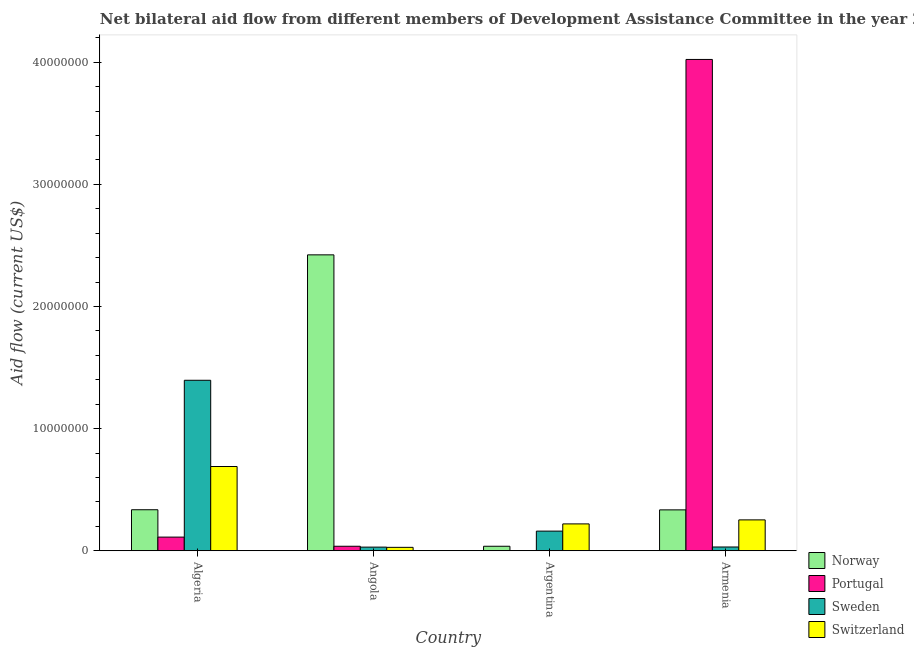How many different coloured bars are there?
Give a very brief answer. 4. Are the number of bars on each tick of the X-axis equal?
Make the answer very short. Yes. What is the label of the 2nd group of bars from the left?
Your response must be concise. Angola. What is the amount of aid given by switzerland in Algeria?
Offer a terse response. 6.90e+06. Across all countries, what is the maximum amount of aid given by portugal?
Ensure brevity in your answer.  4.02e+07. Across all countries, what is the minimum amount of aid given by norway?
Your answer should be very brief. 3.70e+05. In which country was the amount of aid given by sweden maximum?
Provide a short and direct response. Algeria. What is the total amount of aid given by portugal in the graph?
Offer a terse response. 4.17e+07. What is the difference between the amount of aid given by portugal in Angola and that in Armenia?
Make the answer very short. -3.99e+07. What is the difference between the amount of aid given by sweden in Angola and the amount of aid given by switzerland in Algeria?
Provide a succinct answer. -6.60e+06. What is the average amount of aid given by sweden per country?
Keep it short and to the point. 4.04e+06. What is the difference between the amount of aid given by portugal and amount of aid given by switzerland in Angola?
Ensure brevity in your answer.  9.00e+04. What is the ratio of the amount of aid given by norway in Argentina to that in Armenia?
Provide a succinct answer. 0.11. Is the amount of aid given by switzerland in Argentina less than that in Armenia?
Keep it short and to the point. Yes. What is the difference between the highest and the second highest amount of aid given by portugal?
Your answer should be very brief. 3.91e+07. What is the difference between the highest and the lowest amount of aid given by switzerland?
Keep it short and to the point. 6.62e+06. Is it the case that in every country, the sum of the amount of aid given by switzerland and amount of aid given by portugal is greater than the sum of amount of aid given by norway and amount of aid given by sweden?
Your response must be concise. No. What does the 1st bar from the right in Armenia represents?
Offer a very short reply. Switzerland. Is it the case that in every country, the sum of the amount of aid given by norway and amount of aid given by portugal is greater than the amount of aid given by sweden?
Provide a succinct answer. No. What is the difference between two consecutive major ticks on the Y-axis?
Your answer should be very brief. 1.00e+07. Are the values on the major ticks of Y-axis written in scientific E-notation?
Offer a very short reply. No. How many legend labels are there?
Your answer should be compact. 4. How are the legend labels stacked?
Ensure brevity in your answer.  Vertical. What is the title of the graph?
Offer a very short reply. Net bilateral aid flow from different members of Development Assistance Committee in the year 2003. Does "Manufacturing" appear as one of the legend labels in the graph?
Offer a very short reply. No. What is the label or title of the Y-axis?
Keep it short and to the point. Aid flow (current US$). What is the Aid flow (current US$) in Norway in Algeria?
Offer a very short reply. 3.36e+06. What is the Aid flow (current US$) in Portugal in Algeria?
Offer a very short reply. 1.12e+06. What is the Aid flow (current US$) of Sweden in Algeria?
Offer a very short reply. 1.40e+07. What is the Aid flow (current US$) in Switzerland in Algeria?
Provide a short and direct response. 6.90e+06. What is the Aid flow (current US$) in Norway in Angola?
Offer a terse response. 2.42e+07. What is the Aid flow (current US$) in Portugal in Angola?
Keep it short and to the point. 3.70e+05. What is the Aid flow (current US$) in Norway in Argentina?
Ensure brevity in your answer.  3.70e+05. What is the Aid flow (current US$) in Sweden in Argentina?
Offer a terse response. 1.61e+06. What is the Aid flow (current US$) of Switzerland in Argentina?
Ensure brevity in your answer.  2.20e+06. What is the Aid flow (current US$) of Norway in Armenia?
Ensure brevity in your answer.  3.35e+06. What is the Aid flow (current US$) of Portugal in Armenia?
Offer a terse response. 4.02e+07. What is the Aid flow (current US$) of Switzerland in Armenia?
Your answer should be very brief. 2.53e+06. Across all countries, what is the maximum Aid flow (current US$) of Norway?
Give a very brief answer. 2.42e+07. Across all countries, what is the maximum Aid flow (current US$) in Portugal?
Offer a very short reply. 4.02e+07. Across all countries, what is the maximum Aid flow (current US$) of Sweden?
Provide a succinct answer. 1.40e+07. Across all countries, what is the maximum Aid flow (current US$) in Switzerland?
Give a very brief answer. 6.90e+06. Across all countries, what is the minimum Aid flow (current US$) in Portugal?
Your answer should be very brief. 10000. What is the total Aid flow (current US$) of Norway in the graph?
Keep it short and to the point. 3.13e+07. What is the total Aid flow (current US$) in Portugal in the graph?
Make the answer very short. 4.17e+07. What is the total Aid flow (current US$) in Sweden in the graph?
Provide a short and direct response. 1.62e+07. What is the total Aid flow (current US$) of Switzerland in the graph?
Keep it short and to the point. 1.19e+07. What is the difference between the Aid flow (current US$) in Norway in Algeria and that in Angola?
Keep it short and to the point. -2.09e+07. What is the difference between the Aid flow (current US$) in Portugal in Algeria and that in Angola?
Keep it short and to the point. 7.50e+05. What is the difference between the Aid flow (current US$) in Sweden in Algeria and that in Angola?
Your answer should be compact. 1.37e+07. What is the difference between the Aid flow (current US$) in Switzerland in Algeria and that in Angola?
Your response must be concise. 6.62e+06. What is the difference between the Aid flow (current US$) in Norway in Algeria and that in Argentina?
Your answer should be compact. 2.99e+06. What is the difference between the Aid flow (current US$) in Portugal in Algeria and that in Argentina?
Your answer should be very brief. 1.11e+06. What is the difference between the Aid flow (current US$) of Sweden in Algeria and that in Argentina?
Provide a short and direct response. 1.24e+07. What is the difference between the Aid flow (current US$) in Switzerland in Algeria and that in Argentina?
Provide a succinct answer. 4.70e+06. What is the difference between the Aid flow (current US$) in Norway in Algeria and that in Armenia?
Your answer should be very brief. 10000. What is the difference between the Aid flow (current US$) of Portugal in Algeria and that in Armenia?
Make the answer very short. -3.91e+07. What is the difference between the Aid flow (current US$) of Sweden in Algeria and that in Armenia?
Offer a very short reply. 1.36e+07. What is the difference between the Aid flow (current US$) in Switzerland in Algeria and that in Armenia?
Provide a short and direct response. 4.37e+06. What is the difference between the Aid flow (current US$) of Norway in Angola and that in Argentina?
Provide a short and direct response. 2.39e+07. What is the difference between the Aid flow (current US$) in Portugal in Angola and that in Argentina?
Ensure brevity in your answer.  3.60e+05. What is the difference between the Aid flow (current US$) in Sweden in Angola and that in Argentina?
Your answer should be compact. -1.31e+06. What is the difference between the Aid flow (current US$) in Switzerland in Angola and that in Argentina?
Keep it short and to the point. -1.92e+06. What is the difference between the Aid flow (current US$) in Norway in Angola and that in Armenia?
Keep it short and to the point. 2.09e+07. What is the difference between the Aid flow (current US$) of Portugal in Angola and that in Armenia?
Your answer should be very brief. -3.99e+07. What is the difference between the Aid flow (current US$) in Switzerland in Angola and that in Armenia?
Offer a terse response. -2.25e+06. What is the difference between the Aid flow (current US$) in Norway in Argentina and that in Armenia?
Your response must be concise. -2.98e+06. What is the difference between the Aid flow (current US$) in Portugal in Argentina and that in Armenia?
Make the answer very short. -4.02e+07. What is the difference between the Aid flow (current US$) of Sweden in Argentina and that in Armenia?
Provide a succinct answer. 1.30e+06. What is the difference between the Aid flow (current US$) in Switzerland in Argentina and that in Armenia?
Provide a short and direct response. -3.30e+05. What is the difference between the Aid flow (current US$) in Norway in Algeria and the Aid flow (current US$) in Portugal in Angola?
Give a very brief answer. 2.99e+06. What is the difference between the Aid flow (current US$) of Norway in Algeria and the Aid flow (current US$) of Sweden in Angola?
Offer a very short reply. 3.06e+06. What is the difference between the Aid flow (current US$) of Norway in Algeria and the Aid flow (current US$) of Switzerland in Angola?
Your answer should be very brief. 3.08e+06. What is the difference between the Aid flow (current US$) of Portugal in Algeria and the Aid flow (current US$) of Sweden in Angola?
Give a very brief answer. 8.20e+05. What is the difference between the Aid flow (current US$) of Portugal in Algeria and the Aid flow (current US$) of Switzerland in Angola?
Make the answer very short. 8.40e+05. What is the difference between the Aid flow (current US$) of Sweden in Algeria and the Aid flow (current US$) of Switzerland in Angola?
Provide a succinct answer. 1.37e+07. What is the difference between the Aid flow (current US$) in Norway in Algeria and the Aid flow (current US$) in Portugal in Argentina?
Your answer should be compact. 3.35e+06. What is the difference between the Aid flow (current US$) of Norway in Algeria and the Aid flow (current US$) of Sweden in Argentina?
Ensure brevity in your answer.  1.75e+06. What is the difference between the Aid flow (current US$) in Norway in Algeria and the Aid flow (current US$) in Switzerland in Argentina?
Offer a terse response. 1.16e+06. What is the difference between the Aid flow (current US$) in Portugal in Algeria and the Aid flow (current US$) in Sweden in Argentina?
Offer a terse response. -4.90e+05. What is the difference between the Aid flow (current US$) in Portugal in Algeria and the Aid flow (current US$) in Switzerland in Argentina?
Make the answer very short. -1.08e+06. What is the difference between the Aid flow (current US$) in Sweden in Algeria and the Aid flow (current US$) in Switzerland in Argentina?
Provide a succinct answer. 1.18e+07. What is the difference between the Aid flow (current US$) in Norway in Algeria and the Aid flow (current US$) in Portugal in Armenia?
Your response must be concise. -3.69e+07. What is the difference between the Aid flow (current US$) in Norway in Algeria and the Aid flow (current US$) in Sweden in Armenia?
Give a very brief answer. 3.05e+06. What is the difference between the Aid flow (current US$) of Norway in Algeria and the Aid flow (current US$) of Switzerland in Armenia?
Provide a short and direct response. 8.30e+05. What is the difference between the Aid flow (current US$) of Portugal in Algeria and the Aid flow (current US$) of Sweden in Armenia?
Provide a succinct answer. 8.10e+05. What is the difference between the Aid flow (current US$) in Portugal in Algeria and the Aid flow (current US$) in Switzerland in Armenia?
Provide a short and direct response. -1.41e+06. What is the difference between the Aid flow (current US$) in Sweden in Algeria and the Aid flow (current US$) in Switzerland in Armenia?
Ensure brevity in your answer.  1.14e+07. What is the difference between the Aid flow (current US$) in Norway in Angola and the Aid flow (current US$) in Portugal in Argentina?
Offer a very short reply. 2.42e+07. What is the difference between the Aid flow (current US$) in Norway in Angola and the Aid flow (current US$) in Sweden in Argentina?
Your response must be concise. 2.26e+07. What is the difference between the Aid flow (current US$) in Norway in Angola and the Aid flow (current US$) in Switzerland in Argentina?
Ensure brevity in your answer.  2.20e+07. What is the difference between the Aid flow (current US$) of Portugal in Angola and the Aid flow (current US$) of Sweden in Argentina?
Your response must be concise. -1.24e+06. What is the difference between the Aid flow (current US$) of Portugal in Angola and the Aid flow (current US$) of Switzerland in Argentina?
Offer a very short reply. -1.83e+06. What is the difference between the Aid flow (current US$) in Sweden in Angola and the Aid flow (current US$) in Switzerland in Argentina?
Your response must be concise. -1.90e+06. What is the difference between the Aid flow (current US$) in Norway in Angola and the Aid flow (current US$) in Portugal in Armenia?
Your answer should be very brief. -1.60e+07. What is the difference between the Aid flow (current US$) of Norway in Angola and the Aid flow (current US$) of Sweden in Armenia?
Your answer should be very brief. 2.39e+07. What is the difference between the Aid flow (current US$) of Norway in Angola and the Aid flow (current US$) of Switzerland in Armenia?
Offer a very short reply. 2.17e+07. What is the difference between the Aid flow (current US$) of Portugal in Angola and the Aid flow (current US$) of Switzerland in Armenia?
Your response must be concise. -2.16e+06. What is the difference between the Aid flow (current US$) of Sweden in Angola and the Aid flow (current US$) of Switzerland in Armenia?
Make the answer very short. -2.23e+06. What is the difference between the Aid flow (current US$) in Norway in Argentina and the Aid flow (current US$) in Portugal in Armenia?
Your response must be concise. -3.99e+07. What is the difference between the Aid flow (current US$) in Norway in Argentina and the Aid flow (current US$) in Sweden in Armenia?
Give a very brief answer. 6.00e+04. What is the difference between the Aid flow (current US$) of Norway in Argentina and the Aid flow (current US$) of Switzerland in Armenia?
Your answer should be compact. -2.16e+06. What is the difference between the Aid flow (current US$) of Portugal in Argentina and the Aid flow (current US$) of Sweden in Armenia?
Your answer should be compact. -3.00e+05. What is the difference between the Aid flow (current US$) in Portugal in Argentina and the Aid flow (current US$) in Switzerland in Armenia?
Offer a terse response. -2.52e+06. What is the difference between the Aid flow (current US$) in Sweden in Argentina and the Aid flow (current US$) in Switzerland in Armenia?
Give a very brief answer. -9.20e+05. What is the average Aid flow (current US$) in Norway per country?
Offer a terse response. 7.83e+06. What is the average Aid flow (current US$) in Portugal per country?
Provide a succinct answer. 1.04e+07. What is the average Aid flow (current US$) in Sweden per country?
Make the answer very short. 4.04e+06. What is the average Aid flow (current US$) in Switzerland per country?
Offer a very short reply. 2.98e+06. What is the difference between the Aid flow (current US$) in Norway and Aid flow (current US$) in Portugal in Algeria?
Your response must be concise. 2.24e+06. What is the difference between the Aid flow (current US$) of Norway and Aid flow (current US$) of Sweden in Algeria?
Make the answer very short. -1.06e+07. What is the difference between the Aid flow (current US$) of Norway and Aid flow (current US$) of Switzerland in Algeria?
Offer a terse response. -3.54e+06. What is the difference between the Aid flow (current US$) in Portugal and Aid flow (current US$) in Sweden in Algeria?
Your response must be concise. -1.28e+07. What is the difference between the Aid flow (current US$) in Portugal and Aid flow (current US$) in Switzerland in Algeria?
Give a very brief answer. -5.78e+06. What is the difference between the Aid flow (current US$) of Sweden and Aid flow (current US$) of Switzerland in Algeria?
Give a very brief answer. 7.06e+06. What is the difference between the Aid flow (current US$) of Norway and Aid flow (current US$) of Portugal in Angola?
Provide a succinct answer. 2.39e+07. What is the difference between the Aid flow (current US$) of Norway and Aid flow (current US$) of Sweden in Angola?
Provide a succinct answer. 2.39e+07. What is the difference between the Aid flow (current US$) of Norway and Aid flow (current US$) of Switzerland in Angola?
Your answer should be compact. 2.40e+07. What is the difference between the Aid flow (current US$) of Portugal and Aid flow (current US$) of Switzerland in Angola?
Your response must be concise. 9.00e+04. What is the difference between the Aid flow (current US$) of Sweden and Aid flow (current US$) of Switzerland in Angola?
Give a very brief answer. 2.00e+04. What is the difference between the Aid flow (current US$) of Norway and Aid flow (current US$) of Sweden in Argentina?
Your answer should be very brief. -1.24e+06. What is the difference between the Aid flow (current US$) of Norway and Aid flow (current US$) of Switzerland in Argentina?
Provide a short and direct response. -1.83e+06. What is the difference between the Aid flow (current US$) of Portugal and Aid flow (current US$) of Sweden in Argentina?
Your answer should be compact. -1.60e+06. What is the difference between the Aid flow (current US$) in Portugal and Aid flow (current US$) in Switzerland in Argentina?
Ensure brevity in your answer.  -2.19e+06. What is the difference between the Aid flow (current US$) of Sweden and Aid flow (current US$) of Switzerland in Argentina?
Your answer should be compact. -5.90e+05. What is the difference between the Aid flow (current US$) in Norway and Aid flow (current US$) in Portugal in Armenia?
Provide a short and direct response. -3.69e+07. What is the difference between the Aid flow (current US$) in Norway and Aid flow (current US$) in Sweden in Armenia?
Provide a succinct answer. 3.04e+06. What is the difference between the Aid flow (current US$) in Norway and Aid flow (current US$) in Switzerland in Armenia?
Provide a short and direct response. 8.20e+05. What is the difference between the Aid flow (current US$) in Portugal and Aid flow (current US$) in Sweden in Armenia?
Keep it short and to the point. 3.99e+07. What is the difference between the Aid flow (current US$) of Portugal and Aid flow (current US$) of Switzerland in Armenia?
Provide a succinct answer. 3.77e+07. What is the difference between the Aid flow (current US$) of Sweden and Aid flow (current US$) of Switzerland in Armenia?
Offer a very short reply. -2.22e+06. What is the ratio of the Aid flow (current US$) of Norway in Algeria to that in Angola?
Provide a short and direct response. 0.14. What is the ratio of the Aid flow (current US$) of Portugal in Algeria to that in Angola?
Offer a very short reply. 3.03. What is the ratio of the Aid flow (current US$) of Sweden in Algeria to that in Angola?
Make the answer very short. 46.53. What is the ratio of the Aid flow (current US$) of Switzerland in Algeria to that in Angola?
Offer a very short reply. 24.64. What is the ratio of the Aid flow (current US$) in Norway in Algeria to that in Argentina?
Keep it short and to the point. 9.08. What is the ratio of the Aid flow (current US$) of Portugal in Algeria to that in Argentina?
Provide a succinct answer. 112. What is the ratio of the Aid flow (current US$) in Sweden in Algeria to that in Argentina?
Provide a succinct answer. 8.67. What is the ratio of the Aid flow (current US$) of Switzerland in Algeria to that in Argentina?
Ensure brevity in your answer.  3.14. What is the ratio of the Aid flow (current US$) in Portugal in Algeria to that in Armenia?
Give a very brief answer. 0.03. What is the ratio of the Aid flow (current US$) of Sweden in Algeria to that in Armenia?
Your answer should be very brief. 45.03. What is the ratio of the Aid flow (current US$) of Switzerland in Algeria to that in Armenia?
Provide a short and direct response. 2.73. What is the ratio of the Aid flow (current US$) in Norway in Angola to that in Argentina?
Offer a terse response. 65.49. What is the ratio of the Aid flow (current US$) in Sweden in Angola to that in Argentina?
Your answer should be compact. 0.19. What is the ratio of the Aid flow (current US$) of Switzerland in Angola to that in Argentina?
Your answer should be very brief. 0.13. What is the ratio of the Aid flow (current US$) of Norway in Angola to that in Armenia?
Your answer should be compact. 7.23. What is the ratio of the Aid flow (current US$) of Portugal in Angola to that in Armenia?
Provide a succinct answer. 0.01. What is the ratio of the Aid flow (current US$) of Switzerland in Angola to that in Armenia?
Offer a very short reply. 0.11. What is the ratio of the Aid flow (current US$) of Norway in Argentina to that in Armenia?
Give a very brief answer. 0.11. What is the ratio of the Aid flow (current US$) in Sweden in Argentina to that in Armenia?
Your answer should be compact. 5.19. What is the ratio of the Aid flow (current US$) in Switzerland in Argentina to that in Armenia?
Keep it short and to the point. 0.87. What is the difference between the highest and the second highest Aid flow (current US$) of Norway?
Make the answer very short. 2.09e+07. What is the difference between the highest and the second highest Aid flow (current US$) in Portugal?
Ensure brevity in your answer.  3.91e+07. What is the difference between the highest and the second highest Aid flow (current US$) of Sweden?
Provide a short and direct response. 1.24e+07. What is the difference between the highest and the second highest Aid flow (current US$) in Switzerland?
Offer a terse response. 4.37e+06. What is the difference between the highest and the lowest Aid flow (current US$) of Norway?
Offer a very short reply. 2.39e+07. What is the difference between the highest and the lowest Aid flow (current US$) of Portugal?
Keep it short and to the point. 4.02e+07. What is the difference between the highest and the lowest Aid flow (current US$) of Sweden?
Your response must be concise. 1.37e+07. What is the difference between the highest and the lowest Aid flow (current US$) in Switzerland?
Provide a succinct answer. 6.62e+06. 